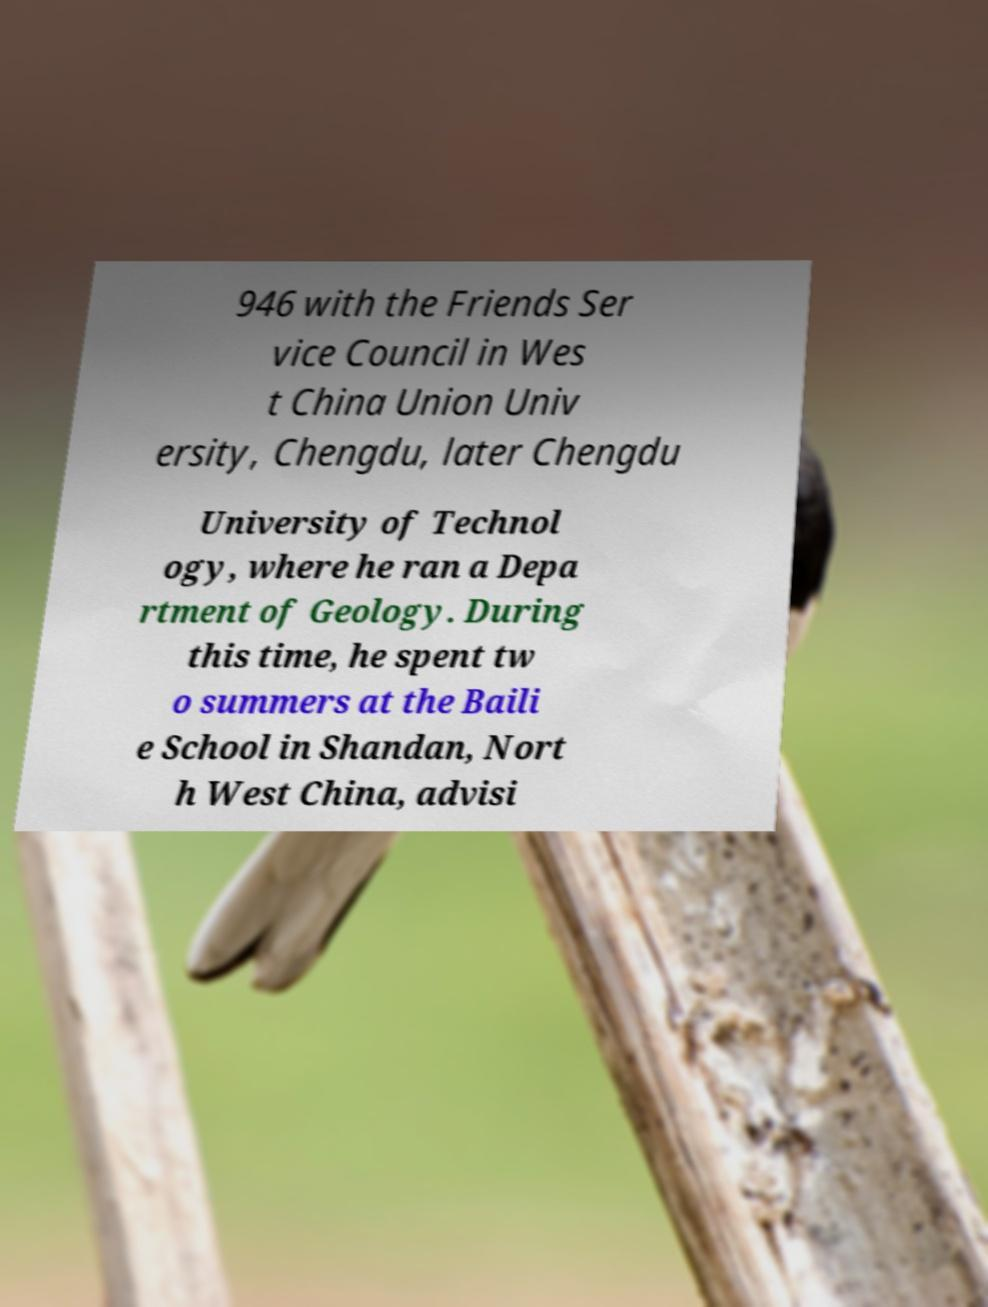Can you read and provide the text displayed in the image?This photo seems to have some interesting text. Can you extract and type it out for me? 946 with the Friends Ser vice Council in Wes t China Union Univ ersity, Chengdu, later Chengdu University of Technol ogy, where he ran a Depa rtment of Geology. During this time, he spent tw o summers at the Baili e School in Shandan, Nort h West China, advisi 